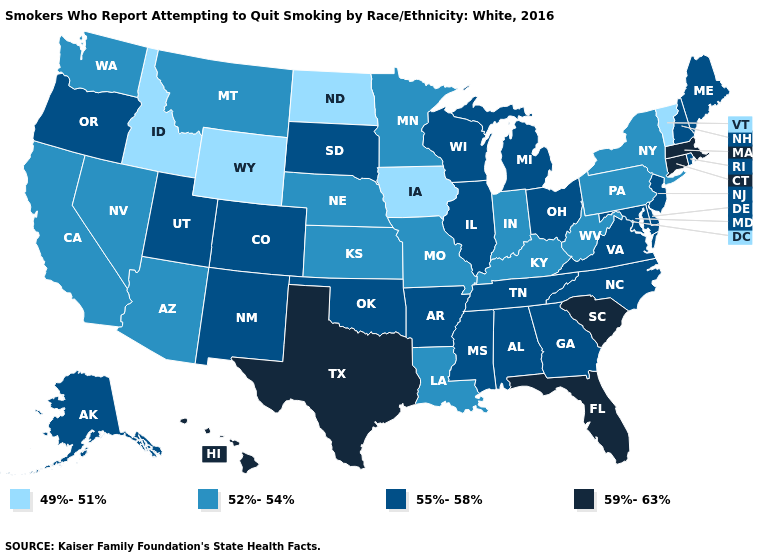Does Wyoming have the lowest value in the West?
Concise answer only. Yes. What is the value of Oklahoma?
Answer briefly. 55%-58%. Does the first symbol in the legend represent the smallest category?
Keep it brief. Yes. What is the value of Colorado?
Give a very brief answer. 55%-58%. Name the states that have a value in the range 49%-51%?
Quick response, please. Idaho, Iowa, North Dakota, Vermont, Wyoming. Name the states that have a value in the range 49%-51%?
Answer briefly. Idaho, Iowa, North Dakota, Vermont, Wyoming. What is the lowest value in states that border West Virginia?
Be succinct. 52%-54%. What is the highest value in states that border Rhode Island?
Answer briefly. 59%-63%. Does South Dakota have the highest value in the MidWest?
Be succinct. Yes. Among the states that border Indiana , does Kentucky have the lowest value?
Answer briefly. Yes. Does the first symbol in the legend represent the smallest category?
Quick response, please. Yes. How many symbols are there in the legend?
Give a very brief answer. 4. What is the highest value in the Northeast ?
Be succinct. 59%-63%. What is the highest value in the West ?
Quick response, please. 59%-63%. 